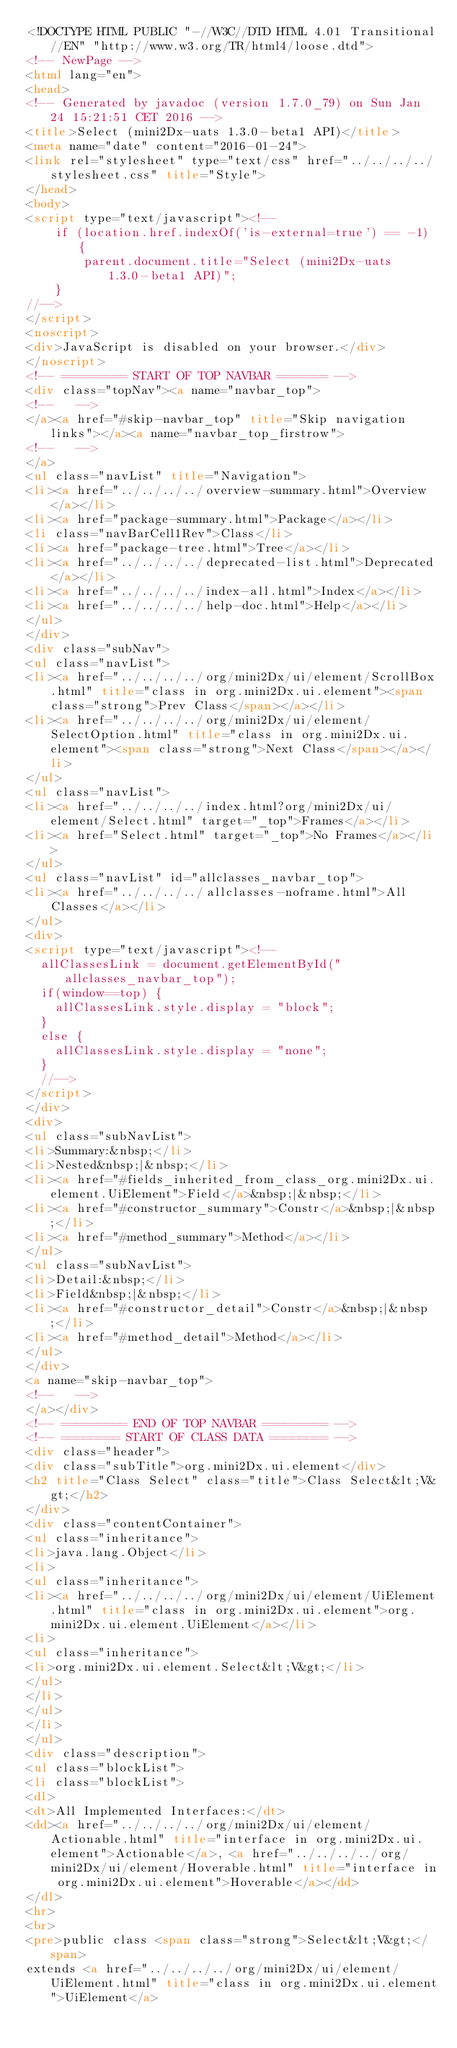Convert code to text. <code><loc_0><loc_0><loc_500><loc_500><_HTML_><!DOCTYPE HTML PUBLIC "-//W3C//DTD HTML 4.01 Transitional//EN" "http://www.w3.org/TR/html4/loose.dtd">
<!-- NewPage -->
<html lang="en">
<head>
<!-- Generated by javadoc (version 1.7.0_79) on Sun Jan 24 15:21:51 CET 2016 -->
<title>Select (mini2Dx-uats 1.3.0-beta1 API)</title>
<meta name="date" content="2016-01-24">
<link rel="stylesheet" type="text/css" href="../../../../stylesheet.css" title="Style">
</head>
<body>
<script type="text/javascript"><!--
    if (location.href.indexOf('is-external=true') == -1) {
        parent.document.title="Select (mini2Dx-uats 1.3.0-beta1 API)";
    }
//-->
</script>
<noscript>
<div>JavaScript is disabled on your browser.</div>
</noscript>
<!-- ========= START OF TOP NAVBAR ======= -->
<div class="topNav"><a name="navbar_top">
<!--   -->
</a><a href="#skip-navbar_top" title="Skip navigation links"></a><a name="navbar_top_firstrow">
<!--   -->
</a>
<ul class="navList" title="Navigation">
<li><a href="../../../../overview-summary.html">Overview</a></li>
<li><a href="package-summary.html">Package</a></li>
<li class="navBarCell1Rev">Class</li>
<li><a href="package-tree.html">Tree</a></li>
<li><a href="../../../../deprecated-list.html">Deprecated</a></li>
<li><a href="../../../../index-all.html">Index</a></li>
<li><a href="../../../../help-doc.html">Help</a></li>
</ul>
</div>
<div class="subNav">
<ul class="navList">
<li><a href="../../../../org/mini2Dx/ui/element/ScrollBox.html" title="class in org.mini2Dx.ui.element"><span class="strong">Prev Class</span></a></li>
<li><a href="../../../../org/mini2Dx/ui/element/SelectOption.html" title="class in org.mini2Dx.ui.element"><span class="strong">Next Class</span></a></li>
</ul>
<ul class="navList">
<li><a href="../../../../index.html?org/mini2Dx/ui/element/Select.html" target="_top">Frames</a></li>
<li><a href="Select.html" target="_top">No Frames</a></li>
</ul>
<ul class="navList" id="allclasses_navbar_top">
<li><a href="../../../../allclasses-noframe.html">All Classes</a></li>
</ul>
<div>
<script type="text/javascript"><!--
  allClassesLink = document.getElementById("allclasses_navbar_top");
  if(window==top) {
    allClassesLink.style.display = "block";
  }
  else {
    allClassesLink.style.display = "none";
  }
  //-->
</script>
</div>
<div>
<ul class="subNavList">
<li>Summary:&nbsp;</li>
<li>Nested&nbsp;|&nbsp;</li>
<li><a href="#fields_inherited_from_class_org.mini2Dx.ui.element.UiElement">Field</a>&nbsp;|&nbsp;</li>
<li><a href="#constructor_summary">Constr</a>&nbsp;|&nbsp;</li>
<li><a href="#method_summary">Method</a></li>
</ul>
<ul class="subNavList">
<li>Detail:&nbsp;</li>
<li>Field&nbsp;|&nbsp;</li>
<li><a href="#constructor_detail">Constr</a>&nbsp;|&nbsp;</li>
<li><a href="#method_detail">Method</a></li>
</ul>
</div>
<a name="skip-navbar_top">
<!--   -->
</a></div>
<!-- ========= END OF TOP NAVBAR ========= -->
<!-- ======== START OF CLASS DATA ======== -->
<div class="header">
<div class="subTitle">org.mini2Dx.ui.element</div>
<h2 title="Class Select" class="title">Class Select&lt;V&gt;</h2>
</div>
<div class="contentContainer">
<ul class="inheritance">
<li>java.lang.Object</li>
<li>
<ul class="inheritance">
<li><a href="../../../../org/mini2Dx/ui/element/UiElement.html" title="class in org.mini2Dx.ui.element">org.mini2Dx.ui.element.UiElement</a></li>
<li>
<ul class="inheritance">
<li>org.mini2Dx.ui.element.Select&lt;V&gt;</li>
</ul>
</li>
</ul>
</li>
</ul>
<div class="description">
<ul class="blockList">
<li class="blockList">
<dl>
<dt>All Implemented Interfaces:</dt>
<dd><a href="../../../../org/mini2Dx/ui/element/Actionable.html" title="interface in org.mini2Dx.ui.element">Actionable</a>, <a href="../../../../org/mini2Dx/ui/element/Hoverable.html" title="interface in org.mini2Dx.ui.element">Hoverable</a></dd>
</dl>
<hr>
<br>
<pre>public class <span class="strong">Select&lt;V&gt;</span>
extends <a href="../../../../org/mini2Dx/ui/element/UiElement.html" title="class in org.mini2Dx.ui.element">UiElement</a></code> 